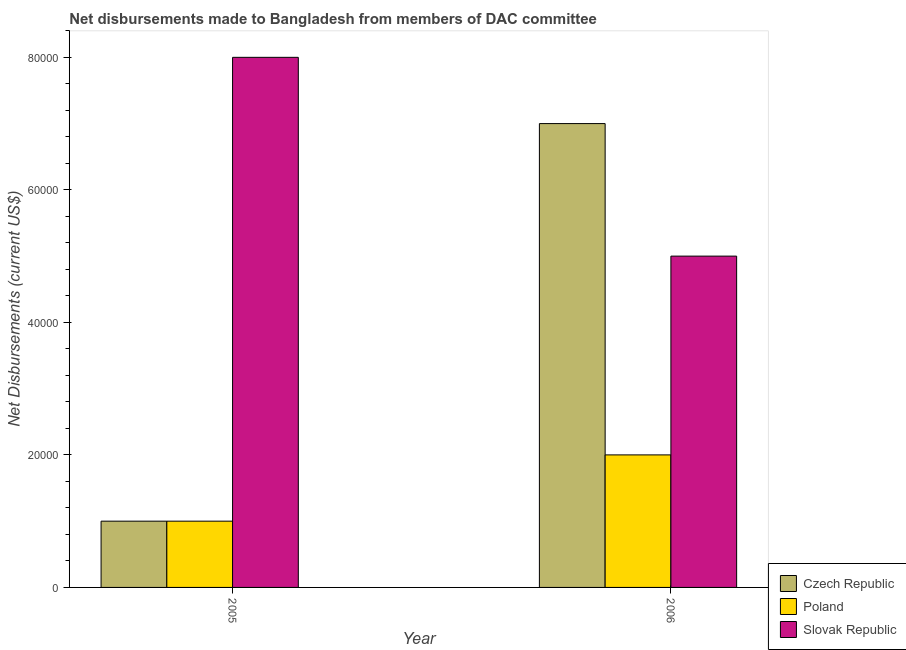How many different coloured bars are there?
Keep it short and to the point. 3. Are the number of bars per tick equal to the number of legend labels?
Your response must be concise. Yes. Are the number of bars on each tick of the X-axis equal?
Make the answer very short. Yes. How many bars are there on the 1st tick from the left?
Your answer should be very brief. 3. How many bars are there on the 1st tick from the right?
Offer a terse response. 3. What is the label of the 2nd group of bars from the left?
Ensure brevity in your answer.  2006. What is the net disbursements made by czech republic in 2006?
Keep it short and to the point. 7.00e+04. Across all years, what is the maximum net disbursements made by slovak republic?
Make the answer very short. 8.00e+04. Across all years, what is the minimum net disbursements made by slovak republic?
Provide a short and direct response. 5.00e+04. What is the total net disbursements made by slovak republic in the graph?
Provide a succinct answer. 1.30e+05. What is the difference between the net disbursements made by slovak republic in 2005 and that in 2006?
Offer a very short reply. 3.00e+04. What is the difference between the net disbursements made by slovak republic in 2006 and the net disbursements made by poland in 2005?
Keep it short and to the point. -3.00e+04. What is the average net disbursements made by czech republic per year?
Make the answer very short. 4.00e+04. In the year 2006, what is the difference between the net disbursements made by slovak republic and net disbursements made by czech republic?
Provide a succinct answer. 0. In how many years, is the net disbursements made by poland greater than 32000 US$?
Offer a very short reply. 0. What is the ratio of the net disbursements made by czech republic in 2005 to that in 2006?
Provide a succinct answer. 0.14. What does the 2nd bar from the left in 2005 represents?
Your answer should be very brief. Poland. What does the 3rd bar from the right in 2006 represents?
Your response must be concise. Czech Republic. Is it the case that in every year, the sum of the net disbursements made by czech republic and net disbursements made by poland is greater than the net disbursements made by slovak republic?
Offer a very short reply. No. How many bars are there?
Provide a short and direct response. 6. How many years are there in the graph?
Your answer should be compact. 2. Are the values on the major ticks of Y-axis written in scientific E-notation?
Keep it short and to the point. No. What is the title of the graph?
Your answer should be compact. Net disbursements made to Bangladesh from members of DAC committee. Does "Ages 15-20" appear as one of the legend labels in the graph?
Make the answer very short. No. What is the label or title of the X-axis?
Provide a short and direct response. Year. What is the label or title of the Y-axis?
Your answer should be compact. Net Disbursements (current US$). What is the Net Disbursements (current US$) in Czech Republic in 2005?
Provide a succinct answer. 10000. What is the Net Disbursements (current US$) of Poland in 2005?
Your answer should be compact. 10000. What is the Net Disbursements (current US$) in Czech Republic in 2006?
Your answer should be very brief. 7.00e+04. What is the Net Disbursements (current US$) in Slovak Republic in 2006?
Offer a very short reply. 5.00e+04. Across all years, what is the maximum Net Disbursements (current US$) in Poland?
Give a very brief answer. 2.00e+04. Across all years, what is the maximum Net Disbursements (current US$) in Slovak Republic?
Provide a short and direct response. 8.00e+04. Across all years, what is the minimum Net Disbursements (current US$) of Czech Republic?
Provide a succinct answer. 10000. What is the total Net Disbursements (current US$) of Czech Republic in the graph?
Keep it short and to the point. 8.00e+04. What is the total Net Disbursements (current US$) in Slovak Republic in the graph?
Offer a very short reply. 1.30e+05. What is the difference between the Net Disbursements (current US$) in Slovak Republic in 2005 and that in 2006?
Your answer should be very brief. 3.00e+04. What is the difference between the Net Disbursements (current US$) in Czech Republic in 2005 and the Net Disbursements (current US$) in Poland in 2006?
Your answer should be compact. -10000. What is the difference between the Net Disbursements (current US$) in Czech Republic in 2005 and the Net Disbursements (current US$) in Slovak Republic in 2006?
Keep it short and to the point. -4.00e+04. What is the difference between the Net Disbursements (current US$) in Poland in 2005 and the Net Disbursements (current US$) in Slovak Republic in 2006?
Your response must be concise. -4.00e+04. What is the average Net Disbursements (current US$) of Czech Republic per year?
Ensure brevity in your answer.  4.00e+04. What is the average Net Disbursements (current US$) of Poland per year?
Your answer should be very brief. 1.50e+04. What is the average Net Disbursements (current US$) in Slovak Republic per year?
Give a very brief answer. 6.50e+04. In the year 2005, what is the difference between the Net Disbursements (current US$) of Poland and Net Disbursements (current US$) of Slovak Republic?
Your answer should be compact. -7.00e+04. In the year 2006, what is the difference between the Net Disbursements (current US$) of Czech Republic and Net Disbursements (current US$) of Poland?
Your answer should be very brief. 5.00e+04. In the year 2006, what is the difference between the Net Disbursements (current US$) of Czech Republic and Net Disbursements (current US$) of Slovak Republic?
Provide a succinct answer. 2.00e+04. What is the ratio of the Net Disbursements (current US$) of Czech Republic in 2005 to that in 2006?
Provide a short and direct response. 0.14. What is the difference between the highest and the second highest Net Disbursements (current US$) in Czech Republic?
Offer a very short reply. 6.00e+04. What is the difference between the highest and the lowest Net Disbursements (current US$) in Slovak Republic?
Keep it short and to the point. 3.00e+04. 